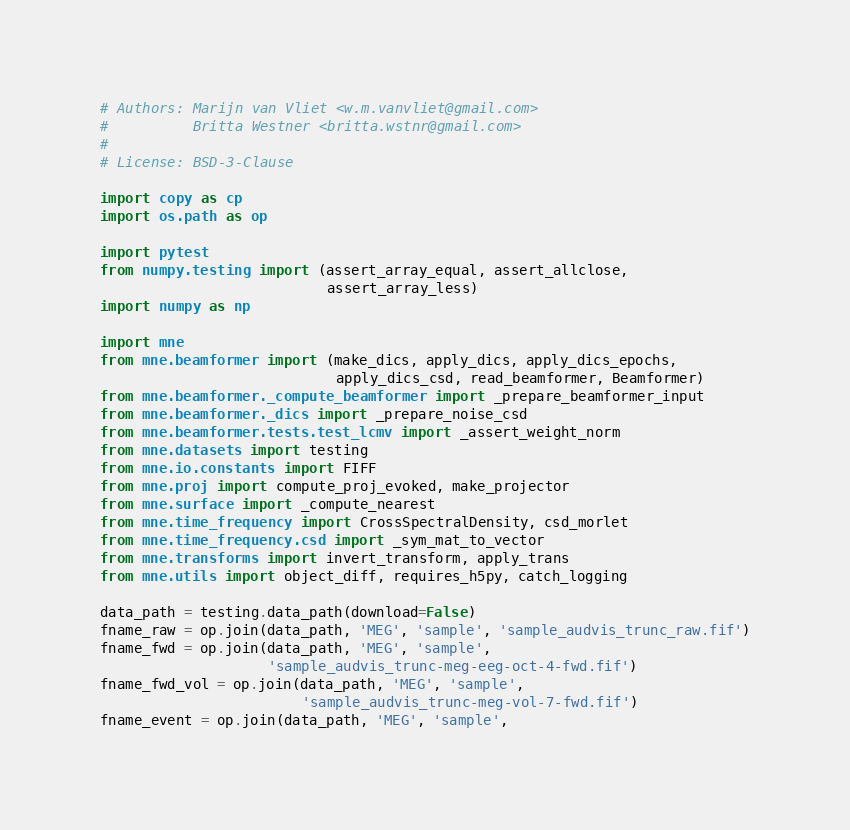<code> <loc_0><loc_0><loc_500><loc_500><_Python_># Authors: Marijn van Vliet <w.m.vanvliet@gmail.com>
#          Britta Westner <britta.wstnr@gmail.com>
#
# License: BSD-3-Clause

import copy as cp
import os.path as op

import pytest
from numpy.testing import (assert_array_equal, assert_allclose,
                           assert_array_less)
import numpy as np

import mne
from mne.beamformer import (make_dics, apply_dics, apply_dics_epochs,
                            apply_dics_csd, read_beamformer, Beamformer)
from mne.beamformer._compute_beamformer import _prepare_beamformer_input
from mne.beamformer._dics import _prepare_noise_csd
from mne.beamformer.tests.test_lcmv import _assert_weight_norm
from mne.datasets import testing
from mne.io.constants import FIFF
from mne.proj import compute_proj_evoked, make_projector
from mne.surface import _compute_nearest
from mne.time_frequency import CrossSpectralDensity, csd_morlet
from mne.time_frequency.csd import _sym_mat_to_vector
from mne.transforms import invert_transform, apply_trans
from mne.utils import object_diff, requires_h5py, catch_logging

data_path = testing.data_path(download=False)
fname_raw = op.join(data_path, 'MEG', 'sample', 'sample_audvis_trunc_raw.fif')
fname_fwd = op.join(data_path, 'MEG', 'sample',
                    'sample_audvis_trunc-meg-eeg-oct-4-fwd.fif')
fname_fwd_vol = op.join(data_path, 'MEG', 'sample',
                        'sample_audvis_trunc-meg-vol-7-fwd.fif')
fname_event = op.join(data_path, 'MEG', 'sample',</code> 